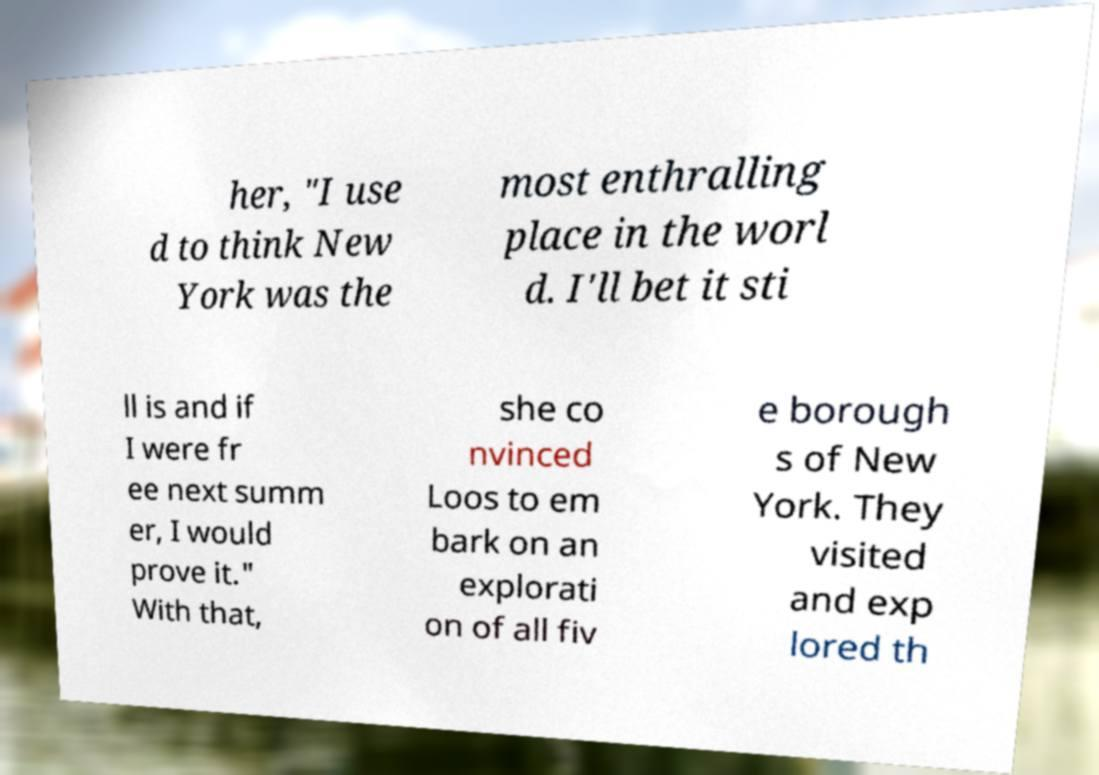I need the written content from this picture converted into text. Can you do that? her, "I use d to think New York was the most enthralling place in the worl d. I'll bet it sti ll is and if I were fr ee next summ er, I would prove it." With that, she co nvinced Loos to em bark on an explorati on of all fiv e borough s of New York. They visited and exp lored th 